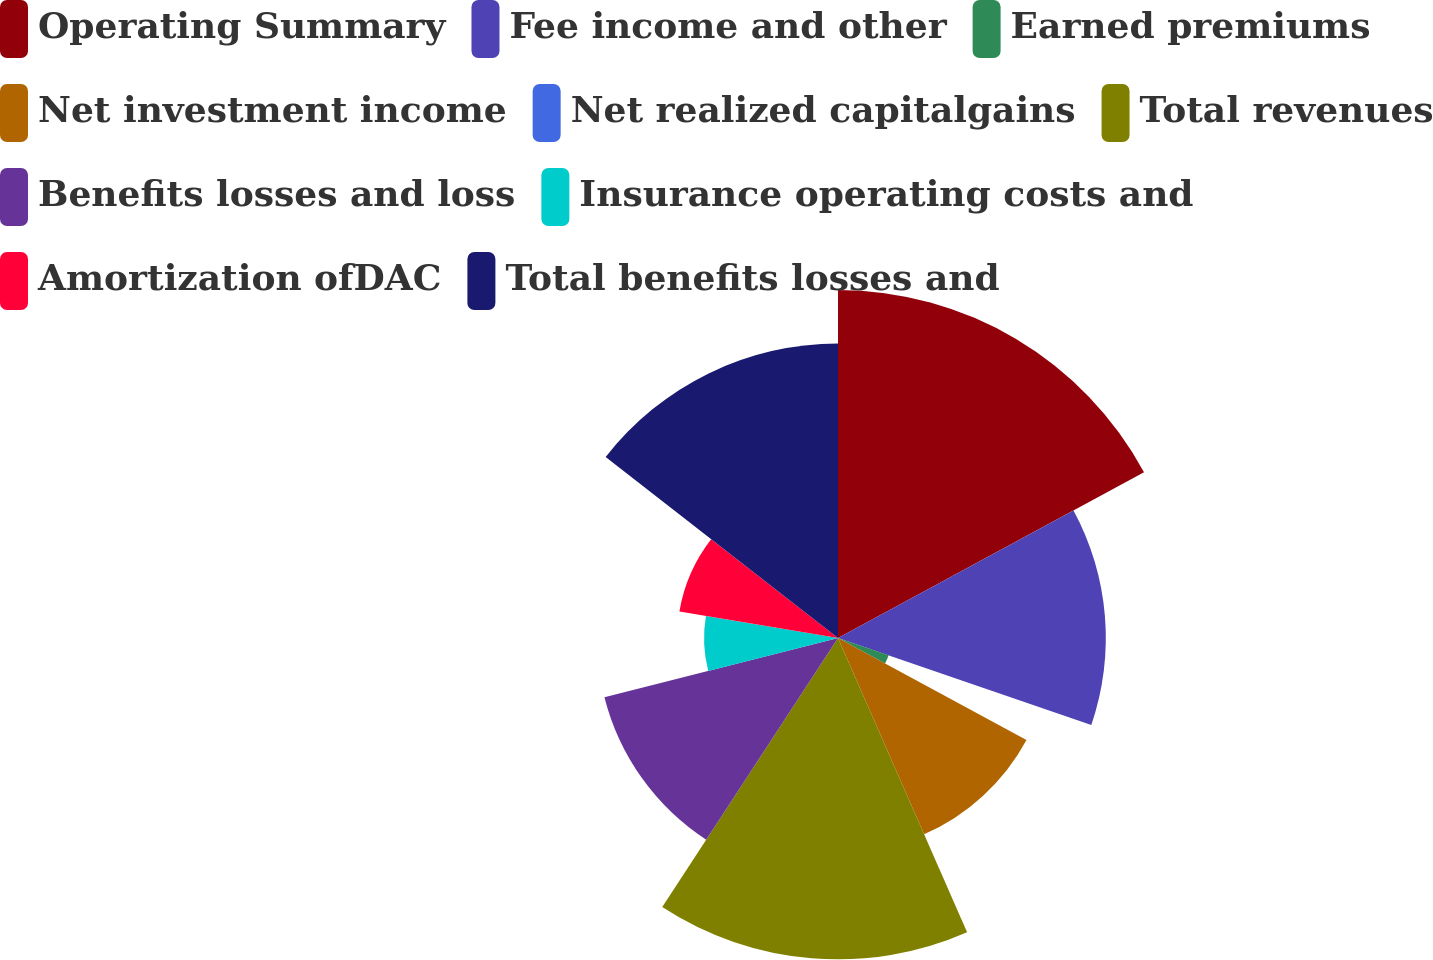<chart> <loc_0><loc_0><loc_500><loc_500><pie_chart><fcel>Operating Summary<fcel>Fee income and other<fcel>Earned premiums<fcel>Net investment income<fcel>Net realized capitalgains<fcel>Total revenues<fcel>Benefits losses and loss<fcel>Insurance operating costs and<fcel>Amortization ofDAC<fcel>Total benefits losses and<nl><fcel>17.1%<fcel>13.16%<fcel>2.63%<fcel>10.53%<fcel>0.0%<fcel>15.79%<fcel>11.84%<fcel>6.58%<fcel>7.9%<fcel>14.47%<nl></chart> 